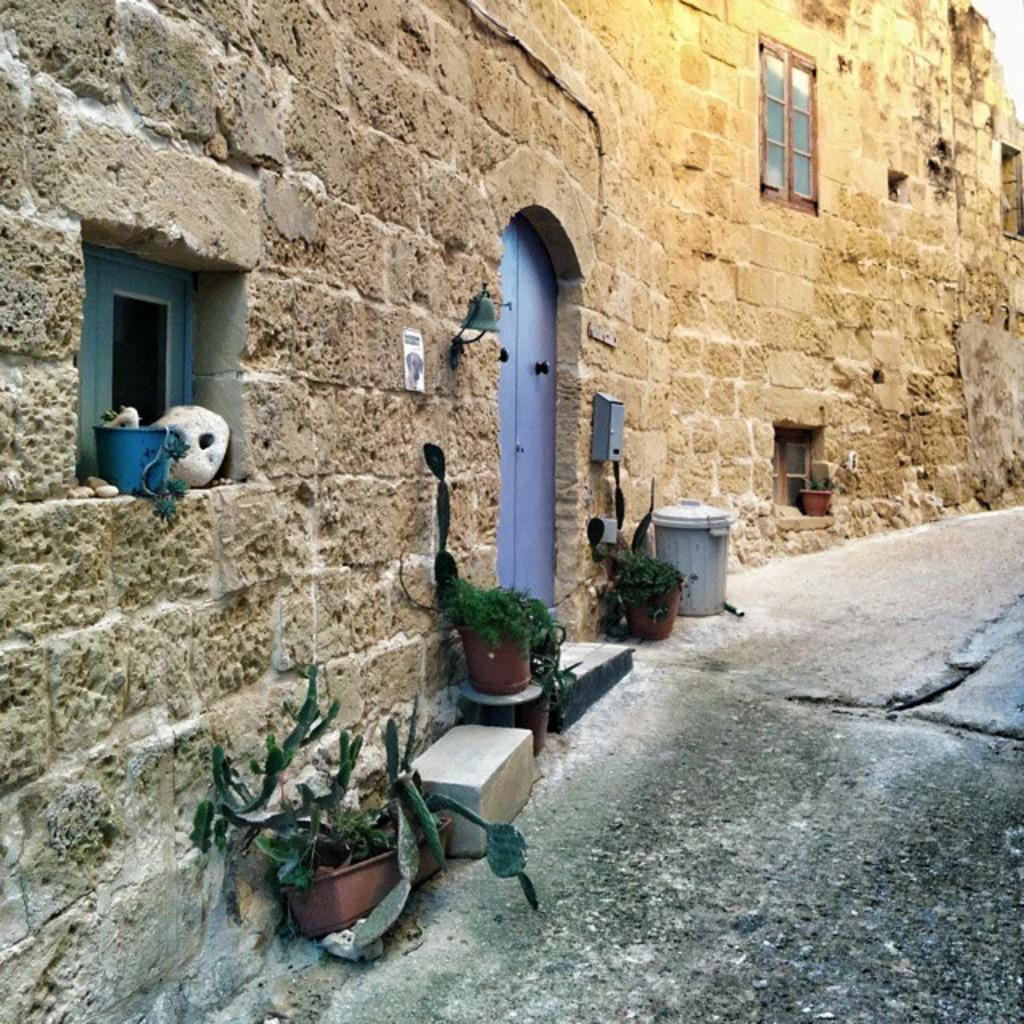Could you give a brief overview of what you see in this image? In this image we can see building, door, windows, house plants and dustbin. 